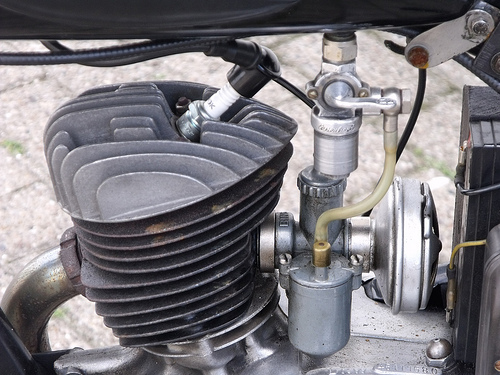<image>
Can you confirm if the spark plug is in front of the engine? No. The spark plug is not in front of the engine. The spatial positioning shows a different relationship between these objects. 